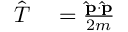<formula> <loc_0><loc_0><loc_500><loc_500>{ \begin{array} { r l } { { \hat { T } } } & = { \frac { \hat { p } \cdot \hat { p } } { 2 m } } } \end{array} } \,</formula> 